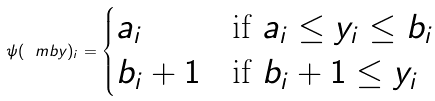Convert formula to latex. <formula><loc_0><loc_0><loc_500><loc_500>\psi ( \ m b y ) _ { i } = \begin{cases} a _ { i } & \text {if $a_{i} \leq y_{i} \leq b_{i}$} \\ b _ { i } + 1 & \text {if $b_{i} +1 \leq y_{i}$} \end{cases}</formula> 